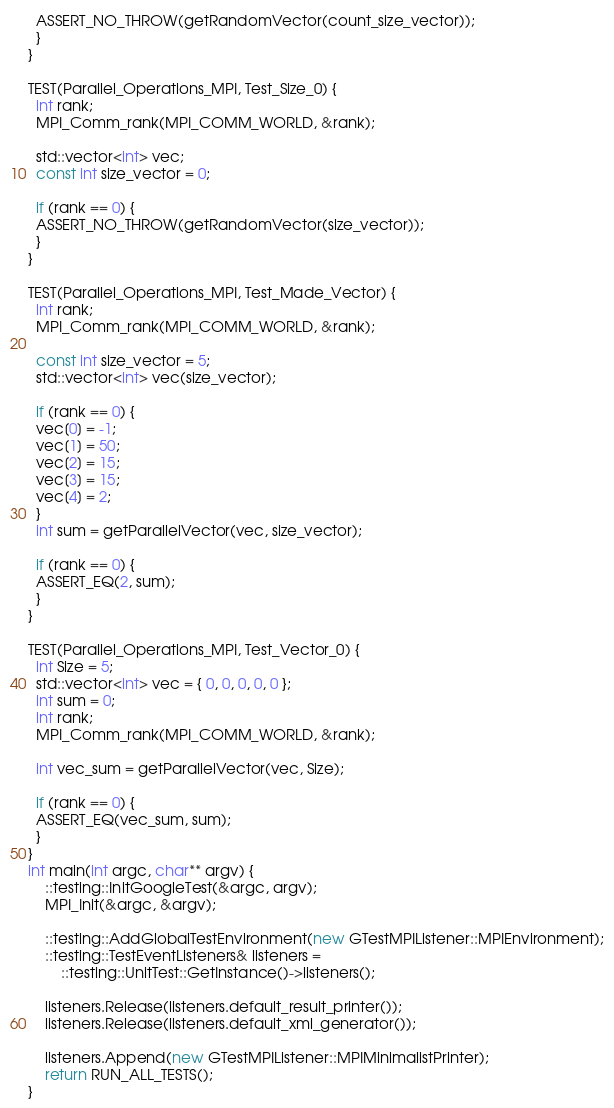Convert code to text. <code><loc_0><loc_0><loc_500><loc_500><_C++_>  ASSERT_NO_THROW(getRandomVector(count_size_vector));
  }
}

TEST(Parallel_Operations_MPI, Test_Size_0) {
  int rank;
  MPI_Comm_rank(MPI_COMM_WORLD, &rank);

  std::vector<int> vec;
  const int size_vector = 0;

  if (rank == 0) {
  ASSERT_NO_THROW(getRandomVector(size_vector));
  }
}

TEST(Parallel_Operations_MPI, Test_Made_Vector) {
  int rank;
  MPI_Comm_rank(MPI_COMM_WORLD, &rank);

  const int size_vector = 5;
  std::vector<int> vec(size_vector);

  if (rank == 0) {
  vec[0] = -1;
  vec[1] = 50;
  vec[2] = 15;
  vec[3] = 15;
  vec[4] = 2;
  }
  int sum = getParallelVector(vec, size_vector);

  if (rank == 0) {
  ASSERT_EQ(2, sum);
  }
}

TEST(Parallel_Operations_MPI, Test_Vector_0) {
  int Size = 5;
  std::vector<int> vec = { 0, 0, 0, 0, 0 };
  int sum = 0;
  int rank;
  MPI_Comm_rank(MPI_COMM_WORLD, &rank);

  int vec_sum = getParallelVector(vec, Size);

  if (rank == 0) {
  ASSERT_EQ(vec_sum, sum);
  }
}
int main(int argc, char** argv) {
    ::testing::InitGoogleTest(&argc, argv);
    MPI_Init(&argc, &argv);

    ::testing::AddGlobalTestEnvironment(new GTestMPIListener::MPIEnvironment);
    ::testing::TestEventListeners& listeners =
        ::testing::UnitTest::GetInstance()->listeners();

    listeners.Release(listeners.default_result_printer());
    listeners.Release(listeners.default_xml_generator());

    listeners.Append(new GTestMPIListener::MPIMinimalistPrinter);
    return RUN_ALL_TESTS();
}
</code> 